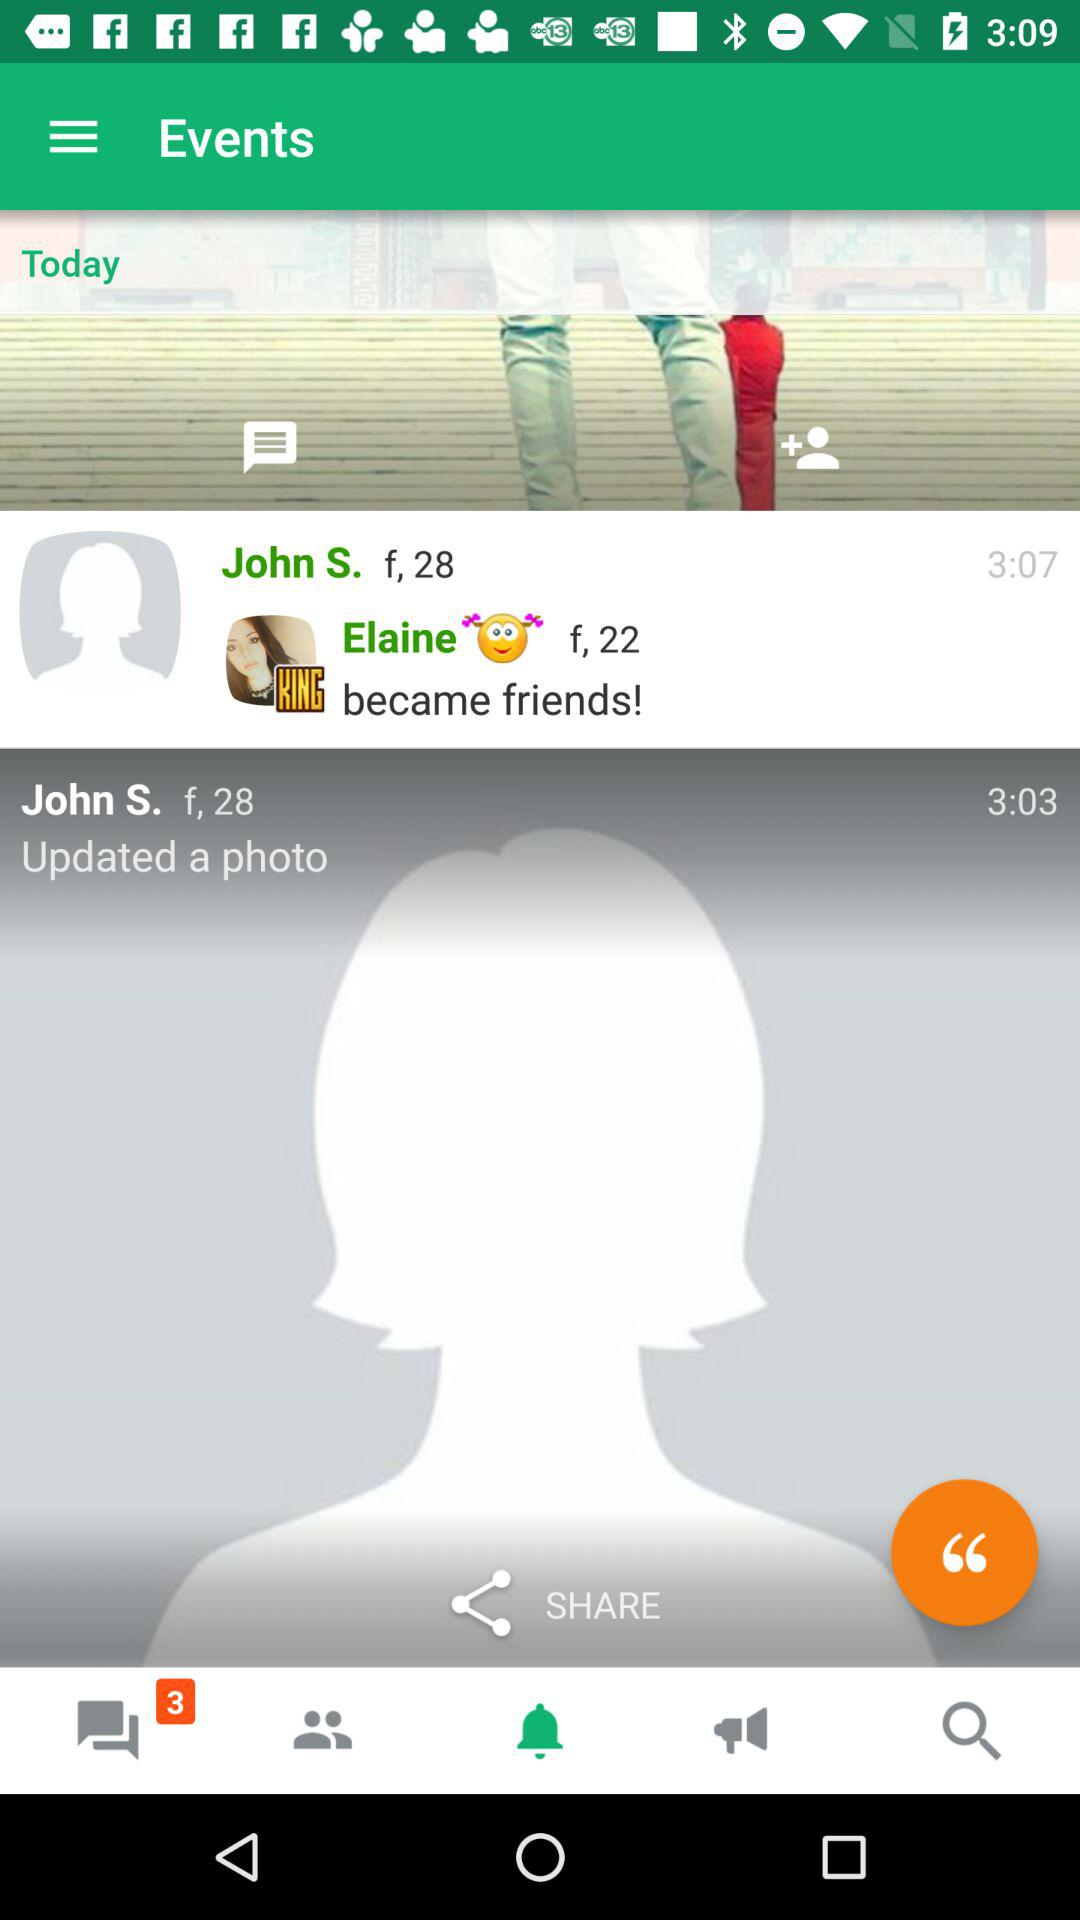What is the gender of John S.? The gender is female. 